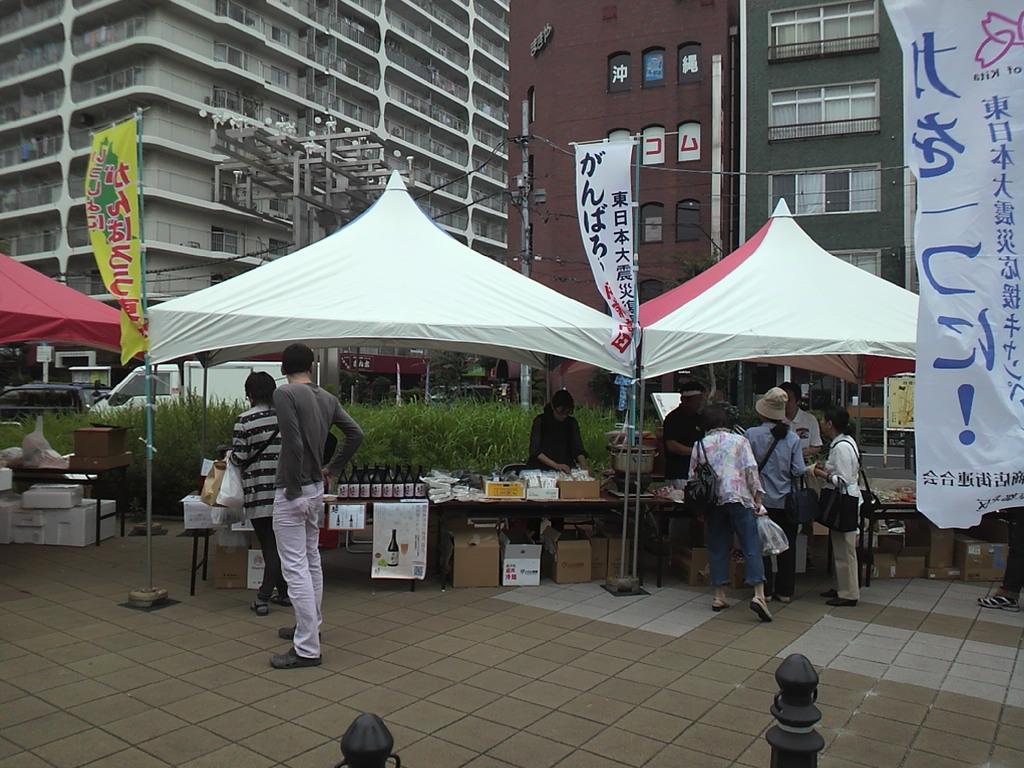How would you summarize this image in a sentence or two? in this image we can see group of persons standing on the ground. One woman is carrying a bag and holding a cover in her hand. In the middle of the image we can see levers items placed on a table. In the background, we can see a group of tents, vehicles, buildings and flags. In the foreground we can see two poles. 